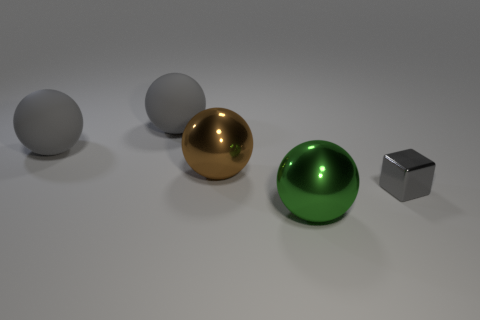What material is the large green object?
Provide a succinct answer. Metal. How many other gray objects have the same material as the small object?
Provide a succinct answer. 0. How many matte objects are either large green objects or cyan things?
Your answer should be compact. 0. Is the shape of the gray object on the right side of the brown shiny object the same as the metallic thing that is in front of the gray shiny cube?
Keep it short and to the point. No. There is a shiny object that is behind the large green ball and left of the gray shiny block; what color is it?
Your response must be concise. Brown. There is a shiny object that is left of the large green thing; is its size the same as the shiny object in front of the tiny gray metallic block?
Your response must be concise. Yes. What number of shiny spheres are the same color as the tiny shiny block?
Provide a short and direct response. 0. How many small things are purple matte cylinders or brown metal objects?
Provide a succinct answer. 0. Is the material of the brown thing on the left side of the large green metal thing the same as the small gray thing?
Offer a very short reply. Yes. The metallic sphere on the right side of the brown metal sphere is what color?
Keep it short and to the point. Green. 